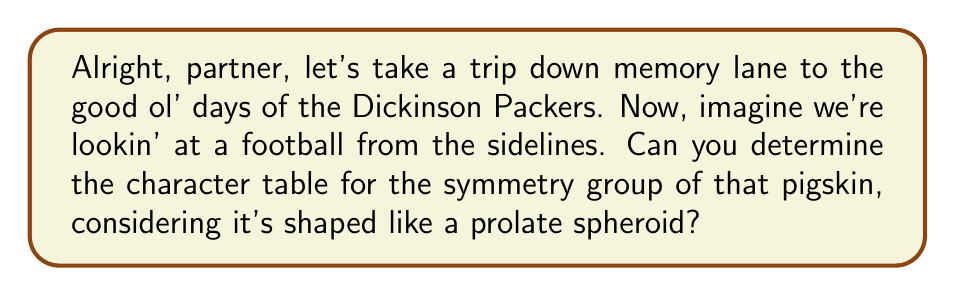Provide a solution to this math problem. Well, let's break this down step-by-step, just like we used to analyze plays back in the day:

1) First, we need to identify the symmetry group of a football. A football has the shape of a prolate spheroid, which has the following symmetries:
   - Identity (E)
   - Rotation by 180° around its long axis (C2)
   - Two 2-fold rotations around axes perpendicular to the long axis (C2' and C2'')
This group is isomorphic to the Klein four-group, V4.

2) The group V4 has four elements, so we'll have four irreducible representations and four conjugacy classes.

3) The conjugacy classes are:
   {E}, {C2}, {C2'}, {C2''}

4) We know that for an abelian group, the number of irreducible representations equals the number of conjugacy classes, and each irreducible representation is one-dimensional.

5) Let's call our irreducible representations χ1, χ2, χ3, and χ4.

6) χ1 is always the trivial representation, which maps every element to 1.

7) For the other representations, we need to ensure that:
   - The character values are either +1 or -1 (since they're one-dimensional)
   - The rows are orthogonal
   - The column corresponding to the identity element E is all 1's

8) With these constraints, we can construct the character table:

   $$
   \begin{array}{c|cccc}
    V_4 & E & C_2 & C_2' & C_2'' \\
    \hline
    \chi_1 & 1 & 1 & 1 & 1 \\
    \chi_2 & 1 & 1 & -1 & -1 \\
    \chi_3 & 1 & -1 & 1 & -1 \\
    \chi_4 & 1 & -1 & -1 & 1
   \end{array}
   $$

This table satisfies all our requirements and correctly represents the character table for the symmetry group of a football.
Answer: $$
\begin{array}{c|cccc}
V_4 & E & C_2 & C_2' & C_2'' \\
\hline
\chi_1 & 1 & 1 & 1 & 1 \\
\chi_2 & 1 & 1 & -1 & -1 \\
\chi_3 & 1 & -1 & 1 & -1 \\
\chi_4 & 1 & -1 & -1 & 1
\end{array}
$$ 